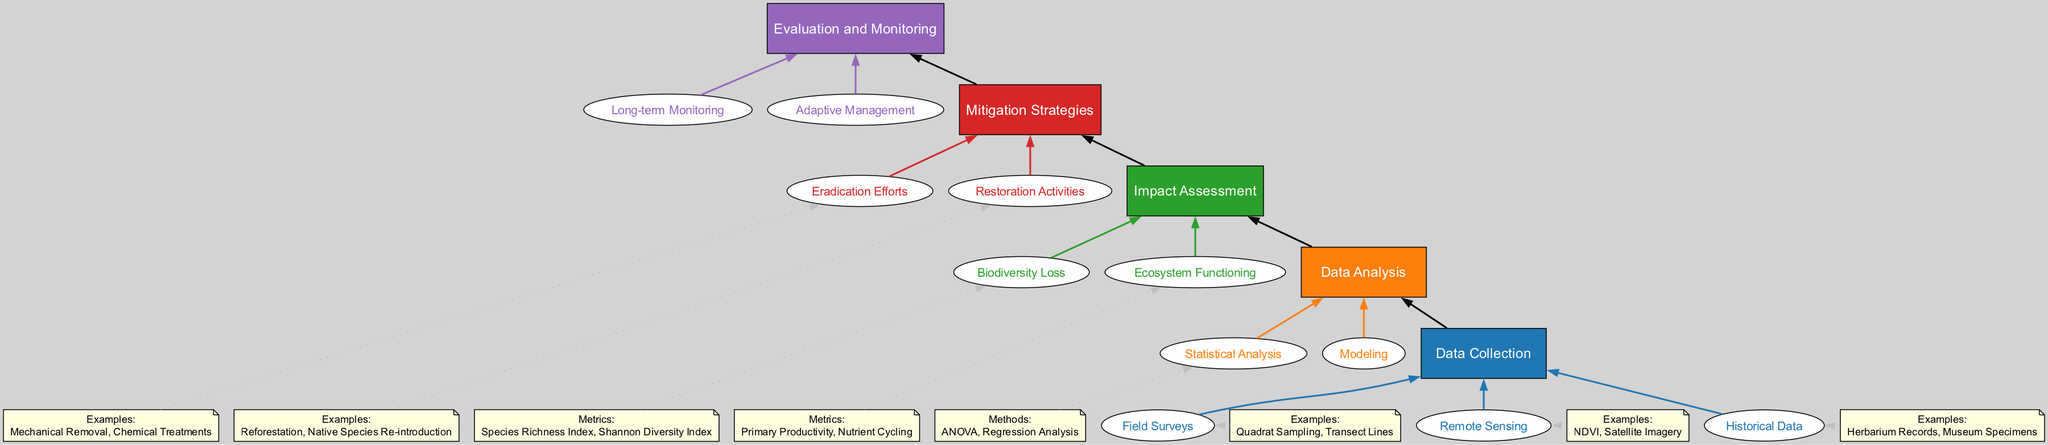What is the first step in the assessment process? The flow chart indicates that the first step in the process is "Data Collection", which is at the bottom of the diagram.
Answer: Data Collection How many sub-elements are under Data Analysis? Under the main element "Data Analysis", there are two sub-elements listed: "Statistical Analysis" and "Modeling". Thus, there are two sub-elements.
Answer: 2 What are the metrics used to assess Ecosystem Functioning? In the diagram, the metrics listed under "Ecosystem Functioning" include "Primary Productivity" and "Nutrient Cycling".
Answer: Primary Productivity, Nutrient Cycling Which main element follows Data Collection? According to the flow of the diagram, "Data Analysis" is directly above "Data Collection", making it the next step.
Answer: Data Analysis Name one example of a method used in Statistical Analysis. The diagram specifies "ANOVA" and "Regression Analysis" under the "Statistical Analysis". Therefore, one example is "ANOVA".
Answer: ANOVA What is the primary focus of the Impact Assessment stage? The primary focus of "Impact Assessment" is to assess the ecological impacts of invasive species based on the data analysis performed in the previous stage.
Answer: Assess ecological impacts What does the Adaptive Management step involve? Within "Evaluation and Monitoring", the "Adaptive Management" step involves adjusting strategies based on monitoring results, which includes "Feedback Loops" and "Continuous Improvement".
Answer: Adjusting strategies How many different strategies are proposed under Mitigation Strategies? The "Mitigation Strategies" section includes two strategies: "Eradication Efforts" and "Restoration Activities", indicating a total of two strategies.
Answer: 2 What is the relationship between the Data Collection and Mitigation Strategies elements? "Data Collection" serves as the foundational step that leads through the processes of "Data Analysis" and "Impact Assessment", ultimately guiding the development of "Mitigation Strategies" in the flow diagram. Therefore, the relationship is sequential—Data Collection is a prerequisite for Mitigation Strategies.
Answer: Sequential relationship 